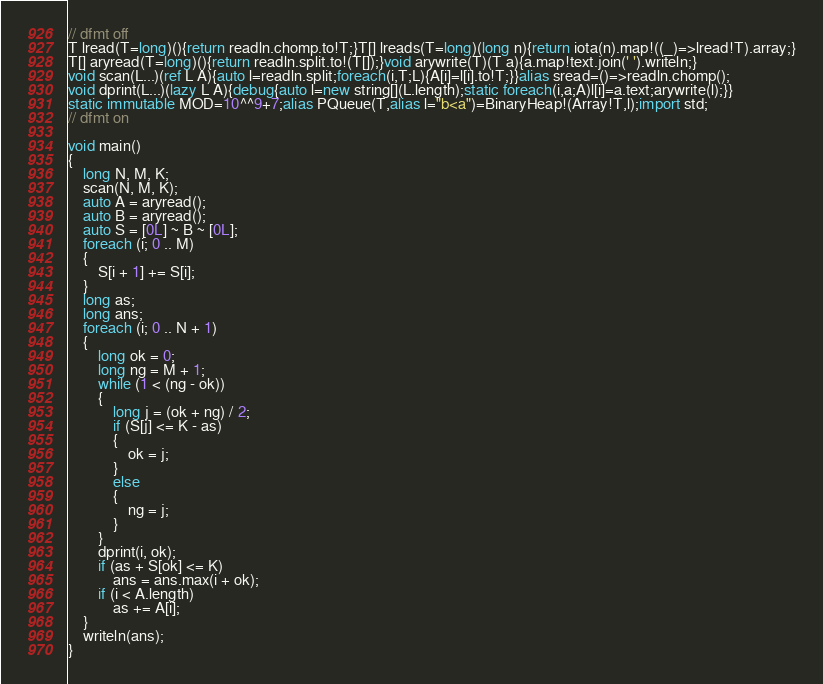<code> <loc_0><loc_0><loc_500><loc_500><_D_>// dfmt off
T lread(T=long)(){return readln.chomp.to!T;}T[] lreads(T=long)(long n){return iota(n).map!((_)=>lread!T).array;}
T[] aryread(T=long)(){return readln.split.to!(T[]);}void arywrite(T)(T a){a.map!text.join(' ').writeln;}
void scan(L...)(ref L A){auto l=readln.split;foreach(i,T;L){A[i]=l[i].to!T;}}alias sread=()=>readln.chomp();
void dprint(L...)(lazy L A){debug{auto l=new string[](L.length);static foreach(i,a;A)l[i]=a.text;arywrite(l);}}
static immutable MOD=10^^9+7;alias PQueue(T,alias l="b<a")=BinaryHeap!(Array!T,l);import std;
// dfmt on

void main()
{
    long N, M, K;
    scan(N, M, K);
    auto A = aryread();
    auto B = aryread();
    auto S = [0L] ~ B ~ [0L];
    foreach (i; 0 .. M)
    {
        S[i + 1] += S[i];
    }
    long as;
    long ans;
    foreach (i; 0 .. N + 1)
    {
        long ok = 0;
        long ng = M + 1;
        while (1 < (ng - ok))
        {
            long j = (ok + ng) / 2;
            if (S[j] <= K - as)
            {
                ok = j;
            }
            else
            {
                ng = j;
            }
        }
        dprint(i, ok);
        if (as + S[ok] <= K)
            ans = ans.max(i + ok);
        if (i < A.length)
            as += A[i];
    }
    writeln(ans);
}
</code> 